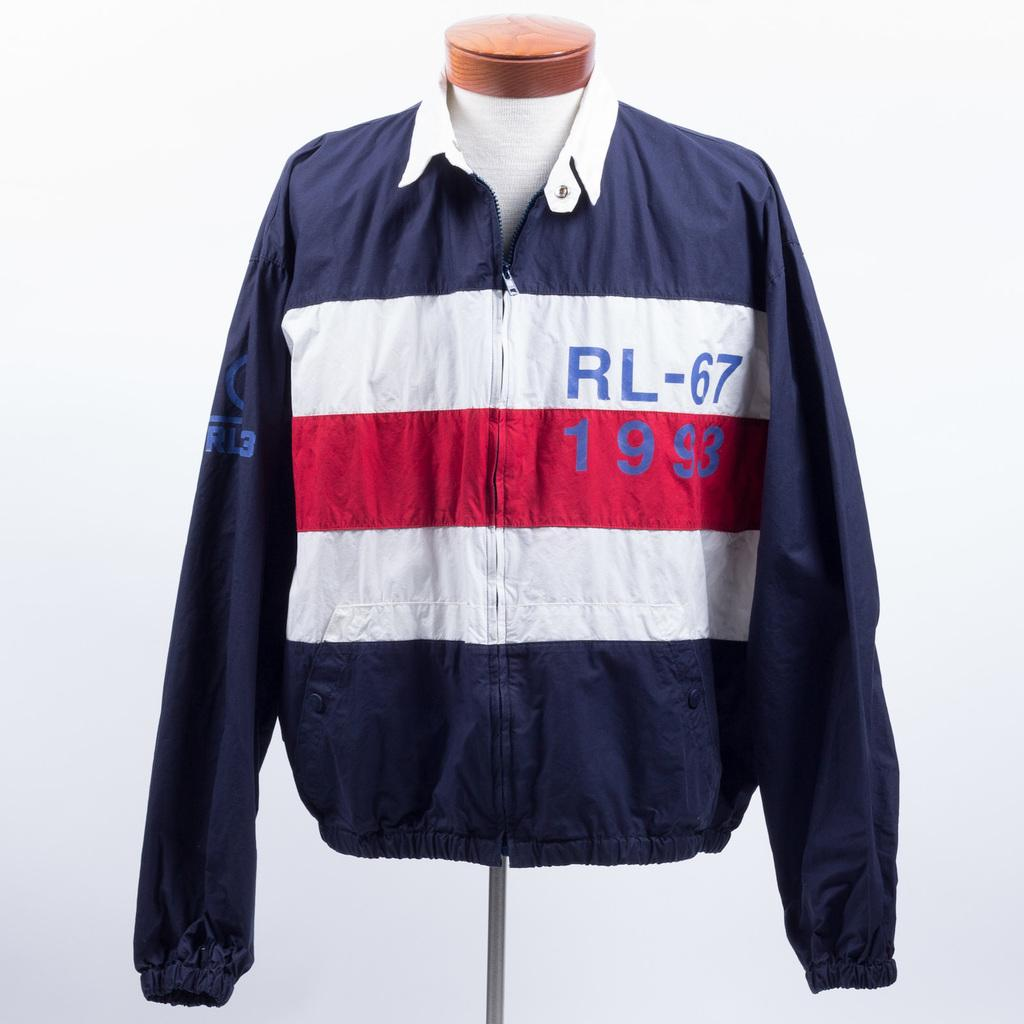<image>
Offer a succinct explanation of the picture presented. A jacket with RL-67 1993 on the chest is displayed on a pole. 